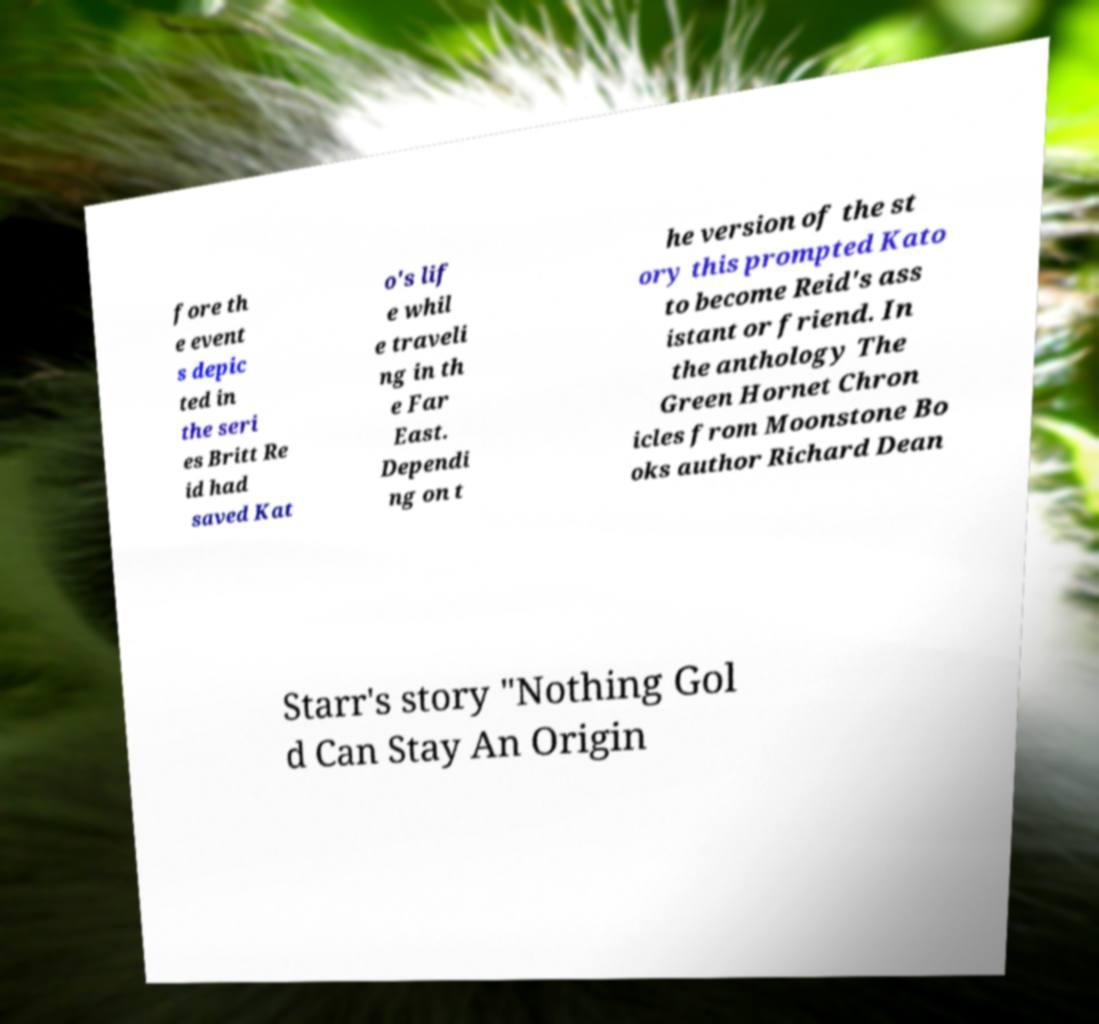Please read and relay the text visible in this image. What does it say? fore th e event s depic ted in the seri es Britt Re id had saved Kat o's lif e whil e traveli ng in th e Far East. Dependi ng on t he version of the st ory this prompted Kato to become Reid's ass istant or friend. In the anthology The Green Hornet Chron icles from Moonstone Bo oks author Richard Dean Starr's story "Nothing Gol d Can Stay An Origin 